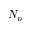Convert formula to latex. <formula><loc_0><loc_0><loc_500><loc_500>N _ { p }</formula> 